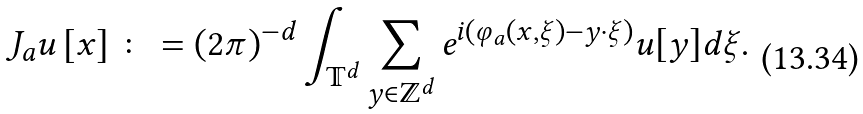<formula> <loc_0><loc_0><loc_500><loc_500>J _ { a } u \left [ x \right ] \colon = ( 2 \pi ) ^ { - d } \int _ { \mathbb { T } ^ { d } } \sum _ { y \in \mathbb { Z } ^ { d } } e ^ { i ( \varphi _ { a } ( x , \xi ) - y \cdot \xi ) } u [ y ] d \xi .</formula> 